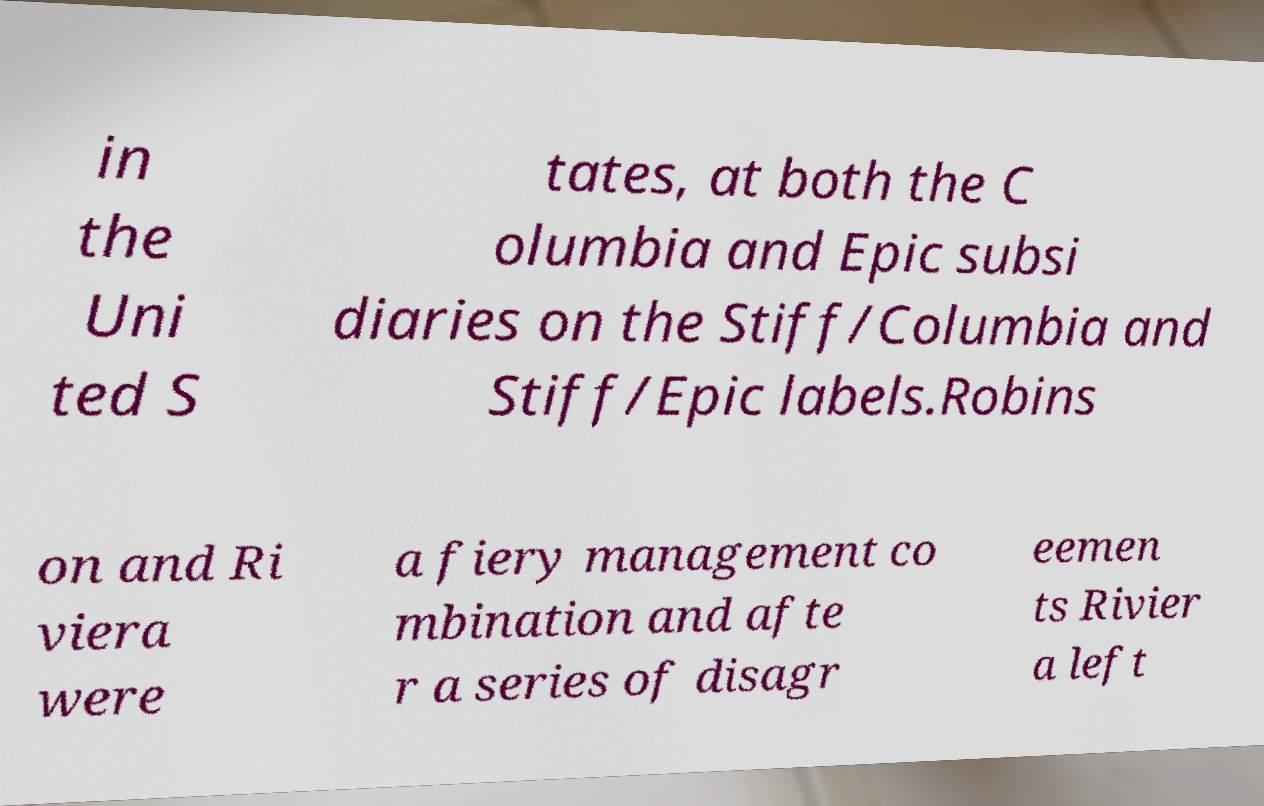For documentation purposes, I need the text within this image transcribed. Could you provide that? in the Uni ted S tates, at both the C olumbia and Epic subsi diaries on the Stiff/Columbia and Stiff/Epic labels.Robins on and Ri viera were a fiery management co mbination and afte r a series of disagr eemen ts Rivier a left 